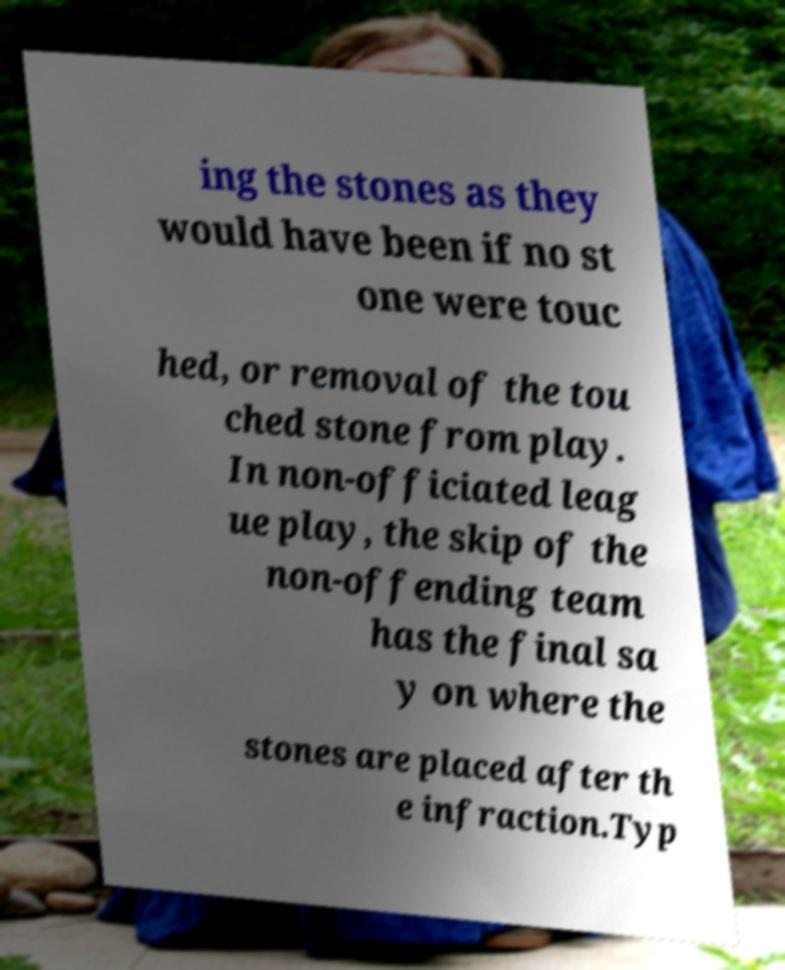Can you accurately transcribe the text from the provided image for me? ing the stones as they would have been if no st one were touc hed, or removal of the tou ched stone from play. In non-officiated leag ue play, the skip of the non-offending team has the final sa y on where the stones are placed after th e infraction.Typ 